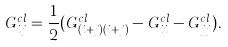<formula> <loc_0><loc_0><loc_500><loc_500>G ^ { c l } _ { i j } = \frac { 1 } { 2 } ( G ^ { c l } _ { ( i + j ) ( i + j ) } - G ^ { c l } _ { i i } - G ^ { c l } _ { j j } ) .</formula> 